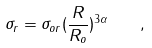<formula> <loc_0><loc_0><loc_500><loc_500>\sigma _ { r } = { \sigma _ { o r } } ( \frac { R } { R _ { o } } ) ^ { 3 \alpha } \quad ,</formula> 